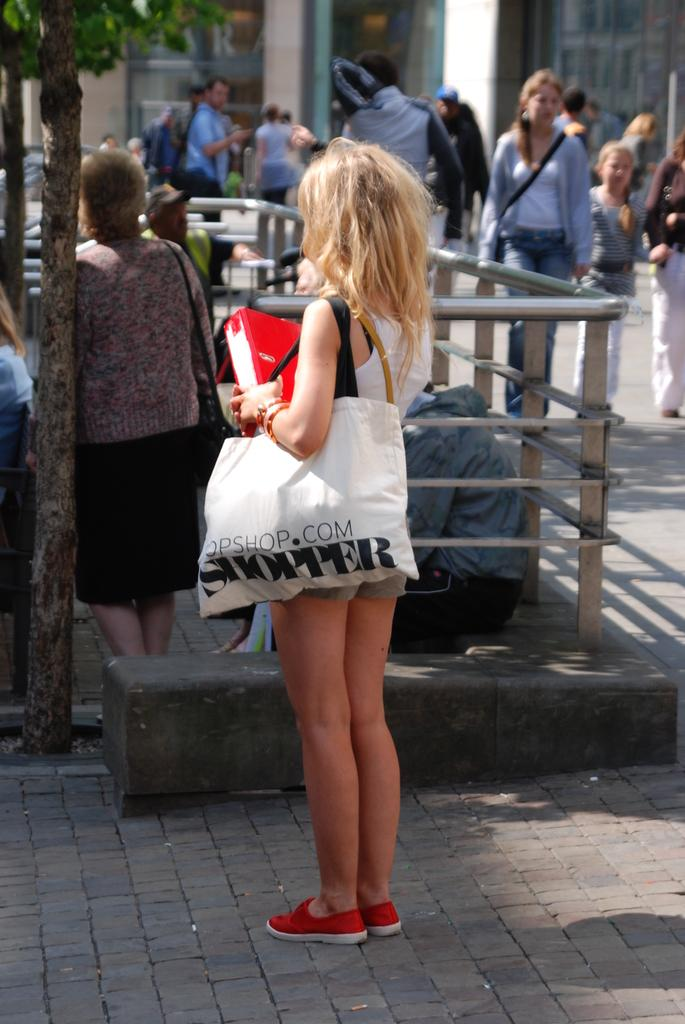<image>
Write a terse but informative summary of the picture. A blonde woman holds a white shopper bag among other people. 